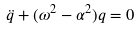<formula> <loc_0><loc_0><loc_500><loc_500>\ddot { q } + ( \omega ^ { 2 } - \alpha ^ { 2 } ) q = 0</formula> 